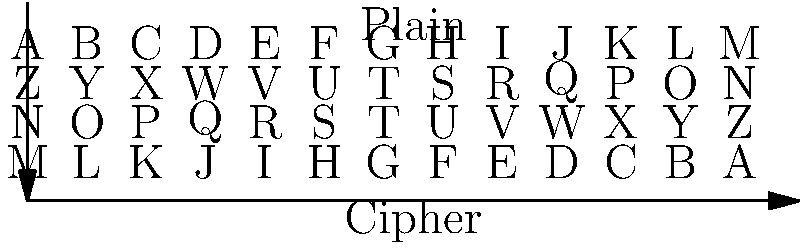Using the substitution cipher table shown above, decode the following message found in a mysterious note left at a crime scene: "NBHGVIB SZKKVM ZG NRWMRTSG" To decode the message, we need to substitute each letter in the cipher text with its corresponding plain text letter according to the table. Let's go through this step-by-step:

1. N → M
2. B → Y
3. H → S
4. G → T
5. V → E
6. I → R
7. B → Y

8. S → H
9. Z → A
10. K → P
11. K → P
12. V → E
13. M → N

14. Z → A
15. G → T

16. N → M
17. R → I
18. W → D
19. M → N
20. R → I
21. T → G
22. S → H
23. G → T

Putting these decoded letters together, we get: "MYSTERY HAPPEN AT MIDNIGHT"
Answer: MYSTERY HAPPEN AT MIDNIGHT 